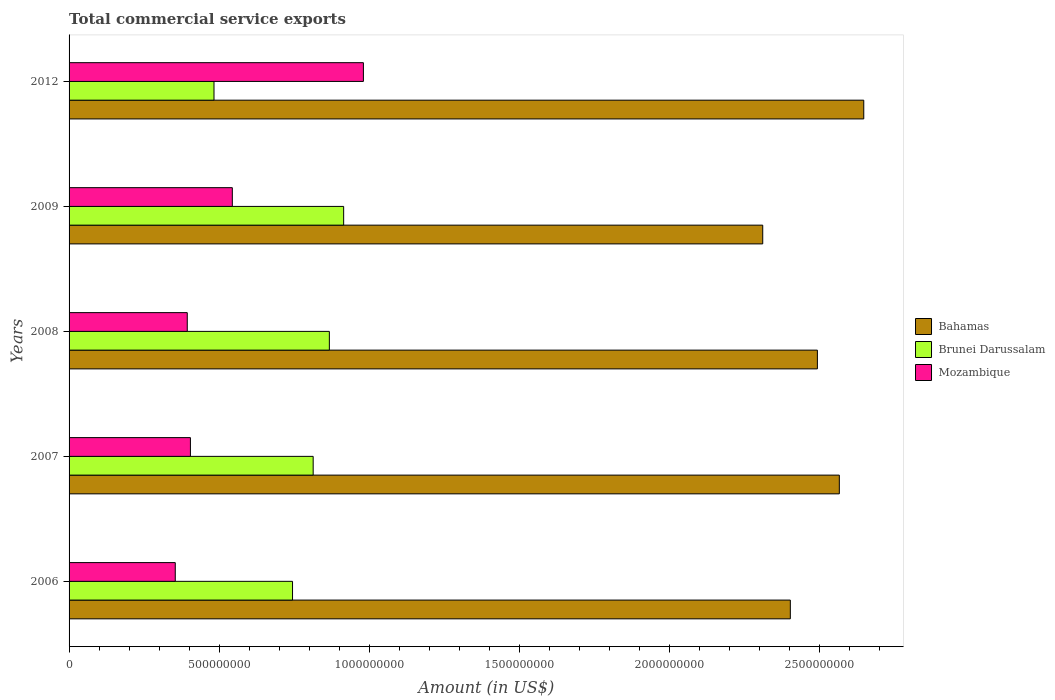Are the number of bars on each tick of the Y-axis equal?
Your response must be concise. Yes. How many bars are there on the 5th tick from the top?
Ensure brevity in your answer.  3. What is the label of the 2nd group of bars from the top?
Your answer should be very brief. 2009. In how many cases, is the number of bars for a given year not equal to the number of legend labels?
Provide a succinct answer. 0. What is the total commercial service exports in Brunei Darussalam in 2012?
Provide a short and direct response. 4.83e+08. Across all years, what is the maximum total commercial service exports in Brunei Darussalam?
Your answer should be compact. 9.15e+08. Across all years, what is the minimum total commercial service exports in Mozambique?
Provide a succinct answer. 3.54e+08. In which year was the total commercial service exports in Bahamas maximum?
Offer a terse response. 2012. What is the total total commercial service exports in Bahamas in the graph?
Make the answer very short. 1.24e+1. What is the difference between the total commercial service exports in Mozambique in 2006 and that in 2009?
Make the answer very short. -1.90e+08. What is the difference between the total commercial service exports in Mozambique in 2008 and the total commercial service exports in Bahamas in 2012?
Your answer should be compact. -2.25e+09. What is the average total commercial service exports in Bahamas per year?
Offer a very short reply. 2.48e+09. In the year 2012, what is the difference between the total commercial service exports in Bahamas and total commercial service exports in Mozambique?
Provide a succinct answer. 1.67e+09. What is the ratio of the total commercial service exports in Bahamas in 2006 to that in 2008?
Ensure brevity in your answer.  0.96. What is the difference between the highest and the second highest total commercial service exports in Mozambique?
Offer a very short reply. 4.37e+08. What is the difference between the highest and the lowest total commercial service exports in Mozambique?
Your answer should be very brief. 6.27e+08. What does the 3rd bar from the top in 2008 represents?
Keep it short and to the point. Bahamas. What does the 2nd bar from the bottom in 2009 represents?
Ensure brevity in your answer.  Brunei Darussalam. How many bars are there?
Your response must be concise. 15. Does the graph contain any zero values?
Your response must be concise. No. Does the graph contain grids?
Make the answer very short. No. Where does the legend appear in the graph?
Offer a very short reply. Center right. How many legend labels are there?
Your answer should be very brief. 3. How are the legend labels stacked?
Keep it short and to the point. Vertical. What is the title of the graph?
Offer a very short reply. Total commercial service exports. What is the label or title of the Y-axis?
Your answer should be compact. Years. What is the Amount (in US$) in Bahamas in 2006?
Make the answer very short. 2.40e+09. What is the Amount (in US$) in Brunei Darussalam in 2006?
Offer a terse response. 7.45e+08. What is the Amount (in US$) of Mozambique in 2006?
Your answer should be compact. 3.54e+08. What is the Amount (in US$) in Bahamas in 2007?
Ensure brevity in your answer.  2.57e+09. What is the Amount (in US$) in Brunei Darussalam in 2007?
Your answer should be compact. 8.13e+08. What is the Amount (in US$) of Mozambique in 2007?
Offer a terse response. 4.04e+08. What is the Amount (in US$) in Bahamas in 2008?
Offer a very short reply. 2.49e+09. What is the Amount (in US$) in Brunei Darussalam in 2008?
Your answer should be very brief. 8.67e+08. What is the Amount (in US$) of Mozambique in 2008?
Provide a succinct answer. 3.94e+08. What is the Amount (in US$) of Bahamas in 2009?
Offer a very short reply. 2.31e+09. What is the Amount (in US$) of Brunei Darussalam in 2009?
Your answer should be very brief. 9.15e+08. What is the Amount (in US$) of Mozambique in 2009?
Offer a terse response. 5.44e+08. What is the Amount (in US$) in Bahamas in 2012?
Offer a terse response. 2.65e+09. What is the Amount (in US$) in Brunei Darussalam in 2012?
Give a very brief answer. 4.83e+08. What is the Amount (in US$) of Mozambique in 2012?
Ensure brevity in your answer.  9.81e+08. Across all years, what is the maximum Amount (in US$) in Bahamas?
Your answer should be very brief. 2.65e+09. Across all years, what is the maximum Amount (in US$) of Brunei Darussalam?
Your response must be concise. 9.15e+08. Across all years, what is the maximum Amount (in US$) in Mozambique?
Give a very brief answer. 9.81e+08. Across all years, what is the minimum Amount (in US$) in Bahamas?
Your response must be concise. 2.31e+09. Across all years, what is the minimum Amount (in US$) in Brunei Darussalam?
Provide a succinct answer. 4.83e+08. Across all years, what is the minimum Amount (in US$) in Mozambique?
Provide a succinct answer. 3.54e+08. What is the total Amount (in US$) of Bahamas in the graph?
Offer a terse response. 1.24e+1. What is the total Amount (in US$) in Brunei Darussalam in the graph?
Provide a short and direct response. 3.82e+09. What is the total Amount (in US$) in Mozambique in the graph?
Keep it short and to the point. 2.68e+09. What is the difference between the Amount (in US$) in Bahamas in 2006 and that in 2007?
Your answer should be compact. -1.63e+08. What is the difference between the Amount (in US$) of Brunei Darussalam in 2006 and that in 2007?
Offer a very short reply. -6.88e+07. What is the difference between the Amount (in US$) in Mozambique in 2006 and that in 2007?
Offer a terse response. -5.05e+07. What is the difference between the Amount (in US$) of Bahamas in 2006 and that in 2008?
Provide a succinct answer. -9.02e+07. What is the difference between the Amount (in US$) in Brunei Darussalam in 2006 and that in 2008?
Offer a terse response. -1.23e+08. What is the difference between the Amount (in US$) in Mozambique in 2006 and that in 2008?
Provide a succinct answer. -4.00e+07. What is the difference between the Amount (in US$) of Bahamas in 2006 and that in 2009?
Your answer should be very brief. 9.20e+07. What is the difference between the Amount (in US$) of Brunei Darussalam in 2006 and that in 2009?
Your response must be concise. -1.70e+08. What is the difference between the Amount (in US$) of Mozambique in 2006 and that in 2009?
Provide a succinct answer. -1.90e+08. What is the difference between the Amount (in US$) of Bahamas in 2006 and that in 2012?
Provide a succinct answer. -2.45e+08. What is the difference between the Amount (in US$) of Brunei Darussalam in 2006 and that in 2012?
Provide a succinct answer. 2.62e+08. What is the difference between the Amount (in US$) of Mozambique in 2006 and that in 2012?
Your answer should be compact. -6.27e+08. What is the difference between the Amount (in US$) of Bahamas in 2007 and that in 2008?
Offer a very short reply. 7.31e+07. What is the difference between the Amount (in US$) of Brunei Darussalam in 2007 and that in 2008?
Keep it short and to the point. -5.39e+07. What is the difference between the Amount (in US$) in Mozambique in 2007 and that in 2008?
Make the answer very short. 1.05e+07. What is the difference between the Amount (in US$) of Bahamas in 2007 and that in 2009?
Offer a very short reply. 2.55e+08. What is the difference between the Amount (in US$) in Brunei Darussalam in 2007 and that in 2009?
Offer a terse response. -1.02e+08. What is the difference between the Amount (in US$) in Mozambique in 2007 and that in 2009?
Provide a short and direct response. -1.40e+08. What is the difference between the Amount (in US$) in Bahamas in 2007 and that in 2012?
Your answer should be compact. -8.14e+07. What is the difference between the Amount (in US$) in Brunei Darussalam in 2007 and that in 2012?
Keep it short and to the point. 3.30e+08. What is the difference between the Amount (in US$) of Mozambique in 2007 and that in 2012?
Make the answer very short. -5.76e+08. What is the difference between the Amount (in US$) of Bahamas in 2008 and that in 2009?
Your answer should be very brief. 1.82e+08. What is the difference between the Amount (in US$) of Brunei Darussalam in 2008 and that in 2009?
Your response must be concise. -4.77e+07. What is the difference between the Amount (in US$) in Mozambique in 2008 and that in 2009?
Ensure brevity in your answer.  -1.50e+08. What is the difference between the Amount (in US$) of Bahamas in 2008 and that in 2012?
Ensure brevity in your answer.  -1.55e+08. What is the difference between the Amount (in US$) of Brunei Darussalam in 2008 and that in 2012?
Ensure brevity in your answer.  3.84e+08. What is the difference between the Amount (in US$) of Mozambique in 2008 and that in 2012?
Provide a succinct answer. -5.87e+08. What is the difference between the Amount (in US$) in Bahamas in 2009 and that in 2012?
Ensure brevity in your answer.  -3.37e+08. What is the difference between the Amount (in US$) of Brunei Darussalam in 2009 and that in 2012?
Your response must be concise. 4.32e+08. What is the difference between the Amount (in US$) of Mozambique in 2009 and that in 2012?
Provide a succinct answer. -4.37e+08. What is the difference between the Amount (in US$) in Bahamas in 2006 and the Amount (in US$) in Brunei Darussalam in 2007?
Your answer should be compact. 1.59e+09. What is the difference between the Amount (in US$) in Bahamas in 2006 and the Amount (in US$) in Mozambique in 2007?
Your answer should be compact. 2.00e+09. What is the difference between the Amount (in US$) in Brunei Darussalam in 2006 and the Amount (in US$) in Mozambique in 2007?
Provide a succinct answer. 3.40e+08. What is the difference between the Amount (in US$) of Bahamas in 2006 and the Amount (in US$) of Brunei Darussalam in 2008?
Make the answer very short. 1.54e+09. What is the difference between the Amount (in US$) in Bahamas in 2006 and the Amount (in US$) in Mozambique in 2008?
Offer a very short reply. 2.01e+09. What is the difference between the Amount (in US$) of Brunei Darussalam in 2006 and the Amount (in US$) of Mozambique in 2008?
Make the answer very short. 3.51e+08. What is the difference between the Amount (in US$) of Bahamas in 2006 and the Amount (in US$) of Brunei Darussalam in 2009?
Provide a succinct answer. 1.49e+09. What is the difference between the Amount (in US$) in Bahamas in 2006 and the Amount (in US$) in Mozambique in 2009?
Keep it short and to the point. 1.86e+09. What is the difference between the Amount (in US$) in Brunei Darussalam in 2006 and the Amount (in US$) in Mozambique in 2009?
Make the answer very short. 2.01e+08. What is the difference between the Amount (in US$) of Bahamas in 2006 and the Amount (in US$) of Brunei Darussalam in 2012?
Offer a terse response. 1.92e+09. What is the difference between the Amount (in US$) of Bahamas in 2006 and the Amount (in US$) of Mozambique in 2012?
Ensure brevity in your answer.  1.42e+09. What is the difference between the Amount (in US$) in Brunei Darussalam in 2006 and the Amount (in US$) in Mozambique in 2012?
Provide a short and direct response. -2.36e+08. What is the difference between the Amount (in US$) of Bahamas in 2007 and the Amount (in US$) of Brunei Darussalam in 2008?
Make the answer very short. 1.70e+09. What is the difference between the Amount (in US$) of Bahamas in 2007 and the Amount (in US$) of Mozambique in 2008?
Your answer should be compact. 2.17e+09. What is the difference between the Amount (in US$) of Brunei Darussalam in 2007 and the Amount (in US$) of Mozambique in 2008?
Keep it short and to the point. 4.20e+08. What is the difference between the Amount (in US$) of Bahamas in 2007 and the Amount (in US$) of Brunei Darussalam in 2009?
Keep it short and to the point. 1.65e+09. What is the difference between the Amount (in US$) of Bahamas in 2007 and the Amount (in US$) of Mozambique in 2009?
Provide a succinct answer. 2.02e+09. What is the difference between the Amount (in US$) of Brunei Darussalam in 2007 and the Amount (in US$) of Mozambique in 2009?
Your response must be concise. 2.69e+08. What is the difference between the Amount (in US$) in Bahamas in 2007 and the Amount (in US$) in Brunei Darussalam in 2012?
Keep it short and to the point. 2.08e+09. What is the difference between the Amount (in US$) of Bahamas in 2007 and the Amount (in US$) of Mozambique in 2012?
Make the answer very short. 1.59e+09. What is the difference between the Amount (in US$) in Brunei Darussalam in 2007 and the Amount (in US$) in Mozambique in 2012?
Keep it short and to the point. -1.67e+08. What is the difference between the Amount (in US$) in Bahamas in 2008 and the Amount (in US$) in Brunei Darussalam in 2009?
Make the answer very short. 1.58e+09. What is the difference between the Amount (in US$) in Bahamas in 2008 and the Amount (in US$) in Mozambique in 2009?
Provide a succinct answer. 1.95e+09. What is the difference between the Amount (in US$) of Brunei Darussalam in 2008 and the Amount (in US$) of Mozambique in 2009?
Your answer should be very brief. 3.23e+08. What is the difference between the Amount (in US$) of Bahamas in 2008 and the Amount (in US$) of Brunei Darussalam in 2012?
Keep it short and to the point. 2.01e+09. What is the difference between the Amount (in US$) in Bahamas in 2008 and the Amount (in US$) in Mozambique in 2012?
Keep it short and to the point. 1.51e+09. What is the difference between the Amount (in US$) of Brunei Darussalam in 2008 and the Amount (in US$) of Mozambique in 2012?
Ensure brevity in your answer.  -1.13e+08. What is the difference between the Amount (in US$) in Bahamas in 2009 and the Amount (in US$) in Brunei Darussalam in 2012?
Give a very brief answer. 1.83e+09. What is the difference between the Amount (in US$) of Bahamas in 2009 and the Amount (in US$) of Mozambique in 2012?
Give a very brief answer. 1.33e+09. What is the difference between the Amount (in US$) of Brunei Darussalam in 2009 and the Amount (in US$) of Mozambique in 2012?
Your answer should be very brief. -6.58e+07. What is the average Amount (in US$) in Bahamas per year?
Offer a very short reply. 2.48e+09. What is the average Amount (in US$) of Brunei Darussalam per year?
Provide a short and direct response. 7.65e+08. What is the average Amount (in US$) in Mozambique per year?
Provide a short and direct response. 5.35e+08. In the year 2006, what is the difference between the Amount (in US$) of Bahamas and Amount (in US$) of Brunei Darussalam?
Offer a terse response. 1.66e+09. In the year 2006, what is the difference between the Amount (in US$) in Bahamas and Amount (in US$) in Mozambique?
Offer a very short reply. 2.05e+09. In the year 2006, what is the difference between the Amount (in US$) of Brunei Darussalam and Amount (in US$) of Mozambique?
Ensure brevity in your answer.  3.91e+08. In the year 2007, what is the difference between the Amount (in US$) of Bahamas and Amount (in US$) of Brunei Darussalam?
Your answer should be very brief. 1.75e+09. In the year 2007, what is the difference between the Amount (in US$) of Bahamas and Amount (in US$) of Mozambique?
Provide a succinct answer. 2.16e+09. In the year 2007, what is the difference between the Amount (in US$) in Brunei Darussalam and Amount (in US$) in Mozambique?
Your response must be concise. 4.09e+08. In the year 2008, what is the difference between the Amount (in US$) of Bahamas and Amount (in US$) of Brunei Darussalam?
Your answer should be compact. 1.63e+09. In the year 2008, what is the difference between the Amount (in US$) of Bahamas and Amount (in US$) of Mozambique?
Make the answer very short. 2.10e+09. In the year 2008, what is the difference between the Amount (in US$) of Brunei Darussalam and Amount (in US$) of Mozambique?
Provide a succinct answer. 4.73e+08. In the year 2009, what is the difference between the Amount (in US$) of Bahamas and Amount (in US$) of Brunei Darussalam?
Your answer should be very brief. 1.40e+09. In the year 2009, what is the difference between the Amount (in US$) of Bahamas and Amount (in US$) of Mozambique?
Offer a terse response. 1.77e+09. In the year 2009, what is the difference between the Amount (in US$) in Brunei Darussalam and Amount (in US$) in Mozambique?
Your answer should be compact. 3.71e+08. In the year 2012, what is the difference between the Amount (in US$) in Bahamas and Amount (in US$) in Brunei Darussalam?
Offer a terse response. 2.16e+09. In the year 2012, what is the difference between the Amount (in US$) of Bahamas and Amount (in US$) of Mozambique?
Offer a terse response. 1.67e+09. In the year 2012, what is the difference between the Amount (in US$) of Brunei Darussalam and Amount (in US$) of Mozambique?
Your answer should be compact. -4.98e+08. What is the ratio of the Amount (in US$) of Bahamas in 2006 to that in 2007?
Give a very brief answer. 0.94. What is the ratio of the Amount (in US$) in Brunei Darussalam in 2006 to that in 2007?
Provide a short and direct response. 0.92. What is the ratio of the Amount (in US$) in Mozambique in 2006 to that in 2007?
Your answer should be compact. 0.88. What is the ratio of the Amount (in US$) in Bahamas in 2006 to that in 2008?
Your answer should be compact. 0.96. What is the ratio of the Amount (in US$) in Brunei Darussalam in 2006 to that in 2008?
Ensure brevity in your answer.  0.86. What is the ratio of the Amount (in US$) of Mozambique in 2006 to that in 2008?
Your answer should be compact. 0.9. What is the ratio of the Amount (in US$) of Bahamas in 2006 to that in 2009?
Offer a very short reply. 1.04. What is the ratio of the Amount (in US$) of Brunei Darussalam in 2006 to that in 2009?
Offer a very short reply. 0.81. What is the ratio of the Amount (in US$) of Mozambique in 2006 to that in 2009?
Your answer should be compact. 0.65. What is the ratio of the Amount (in US$) of Bahamas in 2006 to that in 2012?
Your answer should be very brief. 0.91. What is the ratio of the Amount (in US$) of Brunei Darussalam in 2006 to that in 2012?
Offer a very short reply. 1.54. What is the ratio of the Amount (in US$) of Mozambique in 2006 to that in 2012?
Keep it short and to the point. 0.36. What is the ratio of the Amount (in US$) of Bahamas in 2007 to that in 2008?
Give a very brief answer. 1.03. What is the ratio of the Amount (in US$) of Brunei Darussalam in 2007 to that in 2008?
Provide a short and direct response. 0.94. What is the ratio of the Amount (in US$) in Mozambique in 2007 to that in 2008?
Your answer should be compact. 1.03. What is the ratio of the Amount (in US$) in Bahamas in 2007 to that in 2009?
Offer a very short reply. 1.11. What is the ratio of the Amount (in US$) in Brunei Darussalam in 2007 to that in 2009?
Your answer should be compact. 0.89. What is the ratio of the Amount (in US$) in Mozambique in 2007 to that in 2009?
Provide a short and direct response. 0.74. What is the ratio of the Amount (in US$) in Bahamas in 2007 to that in 2012?
Offer a very short reply. 0.97. What is the ratio of the Amount (in US$) of Brunei Darussalam in 2007 to that in 2012?
Your answer should be very brief. 1.68. What is the ratio of the Amount (in US$) in Mozambique in 2007 to that in 2012?
Offer a terse response. 0.41. What is the ratio of the Amount (in US$) of Bahamas in 2008 to that in 2009?
Your answer should be compact. 1.08. What is the ratio of the Amount (in US$) of Brunei Darussalam in 2008 to that in 2009?
Keep it short and to the point. 0.95. What is the ratio of the Amount (in US$) of Mozambique in 2008 to that in 2009?
Provide a short and direct response. 0.72. What is the ratio of the Amount (in US$) of Bahamas in 2008 to that in 2012?
Your response must be concise. 0.94. What is the ratio of the Amount (in US$) of Brunei Darussalam in 2008 to that in 2012?
Offer a very short reply. 1.8. What is the ratio of the Amount (in US$) of Mozambique in 2008 to that in 2012?
Your answer should be compact. 0.4. What is the ratio of the Amount (in US$) of Bahamas in 2009 to that in 2012?
Provide a succinct answer. 0.87. What is the ratio of the Amount (in US$) of Brunei Darussalam in 2009 to that in 2012?
Offer a very short reply. 1.89. What is the ratio of the Amount (in US$) in Mozambique in 2009 to that in 2012?
Your answer should be compact. 0.55. What is the difference between the highest and the second highest Amount (in US$) of Bahamas?
Ensure brevity in your answer.  8.14e+07. What is the difference between the highest and the second highest Amount (in US$) in Brunei Darussalam?
Your answer should be very brief. 4.77e+07. What is the difference between the highest and the second highest Amount (in US$) in Mozambique?
Provide a short and direct response. 4.37e+08. What is the difference between the highest and the lowest Amount (in US$) in Bahamas?
Offer a terse response. 3.37e+08. What is the difference between the highest and the lowest Amount (in US$) of Brunei Darussalam?
Your answer should be compact. 4.32e+08. What is the difference between the highest and the lowest Amount (in US$) of Mozambique?
Provide a short and direct response. 6.27e+08. 